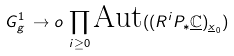Convert formula to latex. <formula><loc_0><loc_0><loc_500><loc_500>\ G ^ { 1 } _ { g } \, \to o \, \prod _ { i \geq 0 } \text {Aut} ( ( R ^ { i } P _ { * } \underline { \mathbb { C } } ) _ { \underline { x } _ { 0 } } )</formula> 